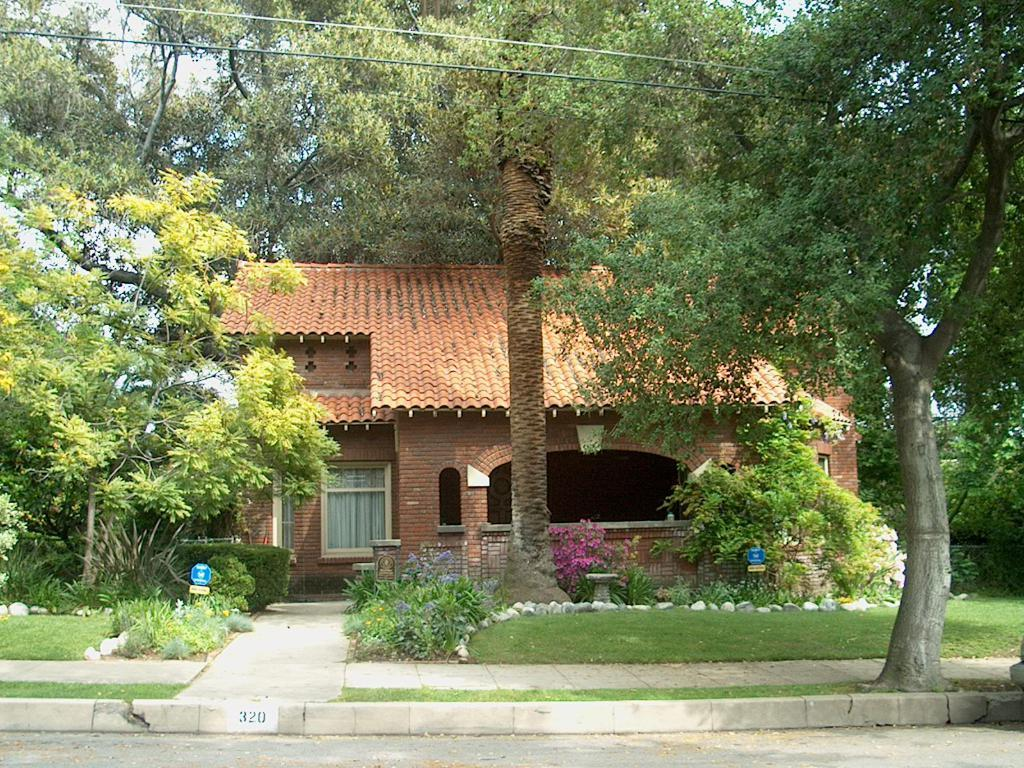What type of surface can be seen in the image? There is a road in the image. What type of vegetation is present in the image? There is grass, trees, plants, and flowers in the image. What other objects can be seen in the image? There are rocks, boards, and a house in the image. What is visible in the background of the image? The sky is visible in the background of the image. Can you tell me how many people are running in the image? There are no people running in the image. What type of arithmetic problem can be solved using the flowers in the image? There is no arithmetic problem present in the image, as it features a variety of natural elements and a house. 